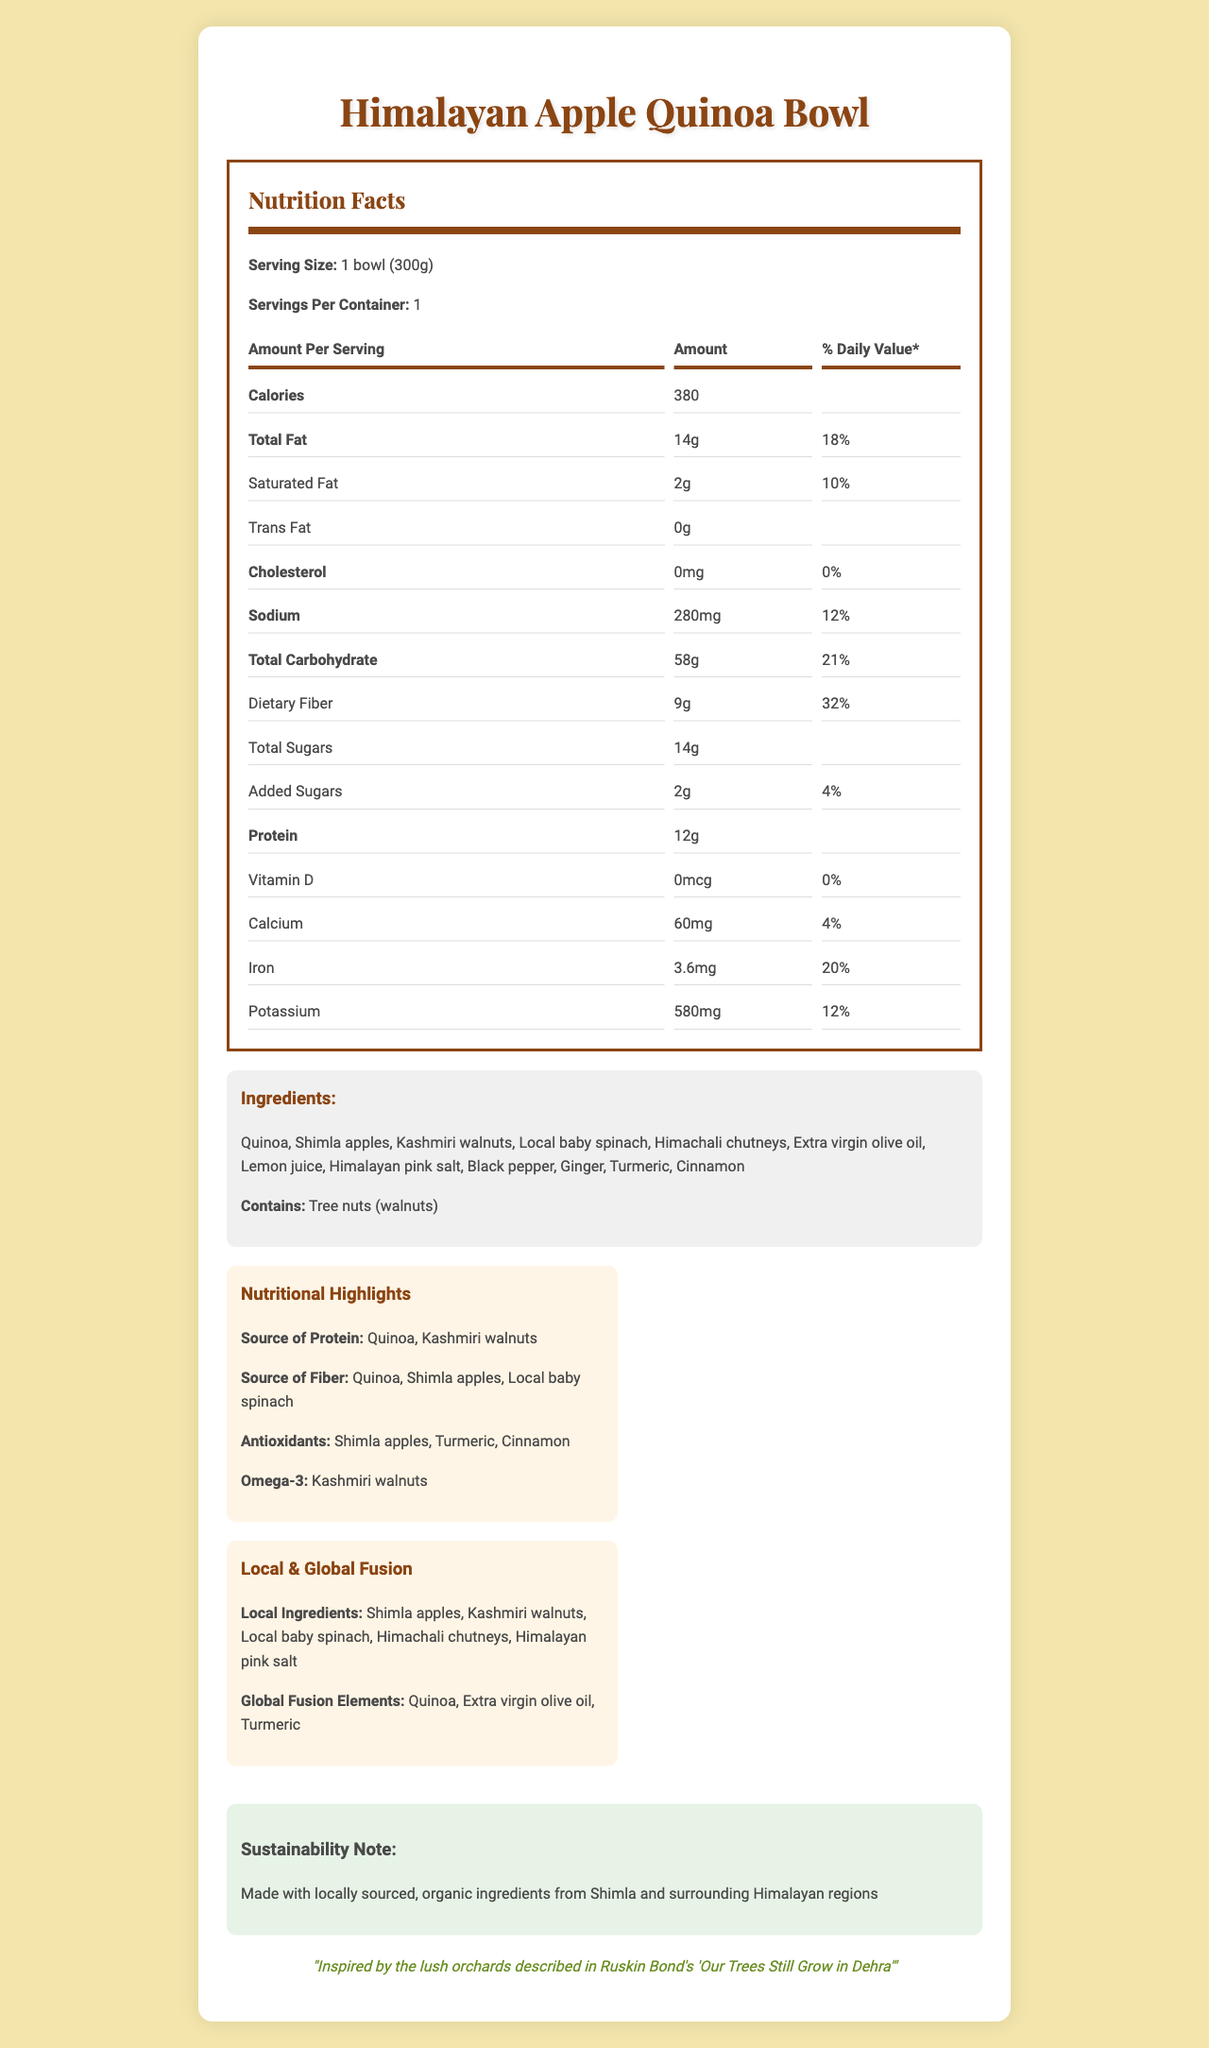what is the serving size for the Himalayan Apple Quinoa Bowl? The document states the serving size as "1 bowl (300g)".
Answer: 1 bowl (300g) how many calories are in one serving of the Himalayan Apple Quinoa Bowl? The document lists the calories per serving as 380.
Answer: 380 what is the total fat content in the Himalayan Apple Quinoa Bowl? The document specifies the total fat amount as 14g.
Answer: 14g list three local ingredients used in the Himalayan Apple Quinoa Bowl These ingredients are listed under the "local ingredients" section in the document.
Answer: Shimla apples, Kashmiri walnuts, Local baby spinach which literary work inspired the Himalayan Apple Quinoa Bowl? The document includes a literary note stating the inspiration from Ruskin Bond's work.
Answer: 'Our Trees Still Grow in Dehra' by Ruskin Bond what is the % Daily Value of dietary fiber in this dish? The document lists the daily value percentage for dietary fiber as 32%.
Answer: 32% is there any cholesterol in the Himalayan Apple Quinoa Bowl? The document states that the cholesterol amount is 0mg, which means there is no cholesterol.
Answer: No (choose the correct option) which of the following is an allergen present in the Himalayan Apple Quinoa Bowl? 
A. Dairy 
B. Gluten 
C. Tree nuts 
D. Soy The document specifically mentions that the dish contains the allergen "Tree nuts (walnuts)".
Answer: C. Tree nuts (choose the correct option) what is the preparation method used for the Himalayan Apple Quinoa Bowl? 
I. Boiled 
II. Fried 
III. Cold-pressed and raw 
IV. Baked The document mentions that the preparation method used is "Cold-pressed and raw".
Answer: III. Cold-pressed and raw does the Himalayan Apple Quinoa Bowl contain any added sugars? The document lists "Added Sugars" with an amount of 2g and a daily value of 4%.
Answer: Yes summarize the main idea of the document. This explanation covers the key details mentioned in the document, including the nutritional facts, ingredient origins, culinary inspiration, and sustainability note.
Answer: The document provides detailed nutritional information about the "Himalayan Apple Quinoa Bowl," including its ingredients, allergens, preparation method, and nutritional value per serving. It highlights the use of local Shimla ingredients and the fusion with global cuisine trends, inspired by Ruskin Bond's literary works. The dish is noted for its sustainability through the use of organic and locally sourced ingredients. what is the source of omega-3 in the Himalayan Apple Quinoa Bowl? The document lists Kashmiri walnuts as the source of omega-3.
Answer: Kashmiri walnuts how much potassium does one serving of the Himalayan Apple Quinoa Bowl contain? The document specifies that the potassium content per serving is 580mg.
Answer: 580mg how many grams of protein are present in one serving? The document states that there are 12 grams of protein in one serving.
Answer: 12g what is the sustainability note provided in the document? The document mentions that the dish is made with locally sourced, organic ingredients from Shimla and surrounding Himalayan regions.
Answer: Made with locally sourced, organic ingredients from Shimla and surrounding Himalayan regions is turmeric a local ingredient used in the dish? The document lists turmeric under "global fusion elements," not as a local ingredient.
Answer: No what cooking method does the document suggest was used for the dish? The document states that the preparation method is "Cold-pressed and raw".
Answer: Cold-pressed and raw which minerals are listed with their daily values in the document? The document provides the daily values for calcium (4%), iron (20%), and potassium (12%).
Answer: Calcium, Iron, Potassium what is the dietary fiber content in grams in one serving of the Himalayan Apple Quinoa Bowl? The document lists the dietary fiber content as 9 grams.
Answer: 9g can you determine the exact recipe for the Himalayan Apple Quinoa Bowl? The document provides the ingredients but does not detail the exact recipe or preparation instructions.
Answer: Not enough information 